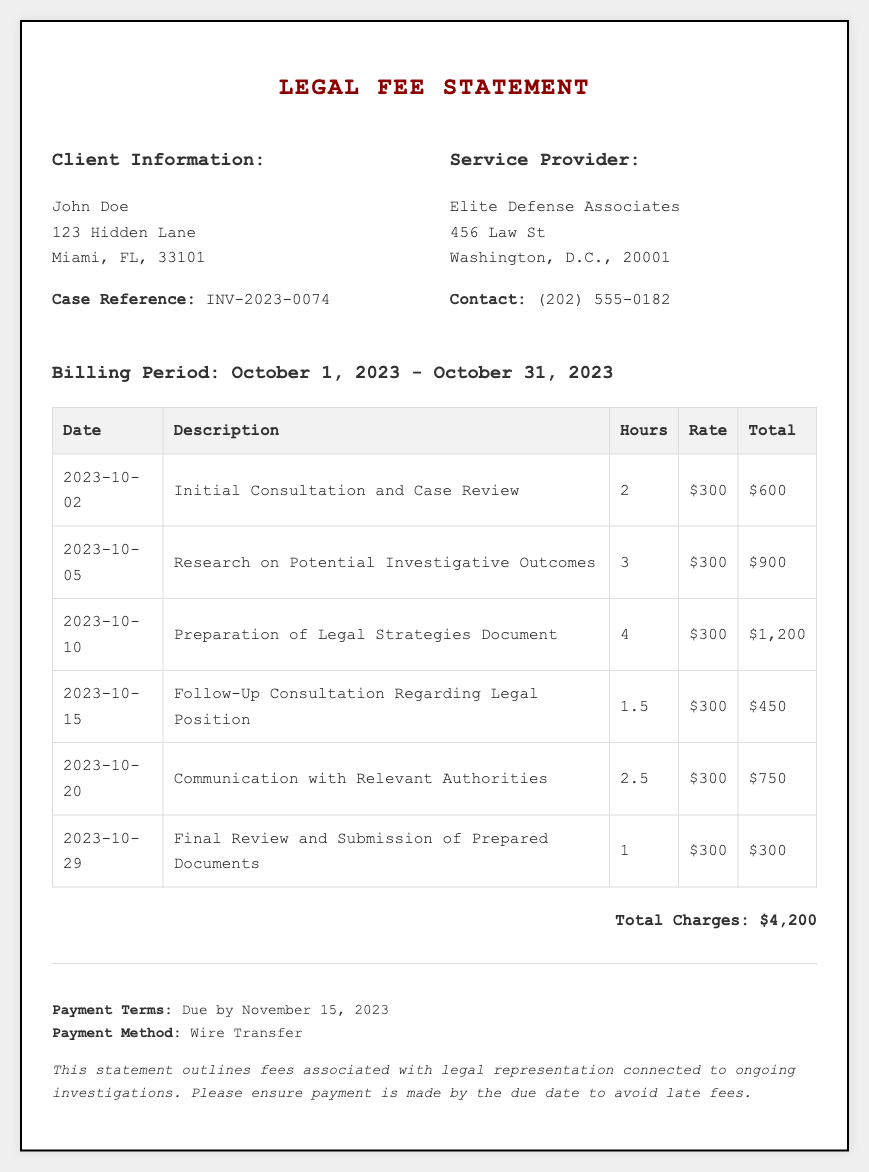What is the client's name? The client's name is presented at the top of the document under Client Information.
Answer: John Doe What is the total amount charged? The total amount charged is summarized at the bottom of the document in the total charges section.
Answer: $4,200 What is the billing period covered in this statement? The billing period is clearly mentioned in the header section of the document.
Answer: October 1, 2023 - October 31, 2023 How many hours were billed for the "Preparation of Legal Strategies Document"? The number of hours for this specific entry is listed in the corresponding row of the table.
Answer: 4 What was the rate per hour charged for services? The rate per hour is consistent across all entries in the table, found in the Rate column.
Answer: $300 What date was the "Final Review and Submission of Prepared Documents"? The date is the first entry in the corresponding row of the table for that service.
Answer: 2023-10-29 What type of payment method is accepted? The accepted payment method is mentioned in the footer of the document.
Answer: Wire Transfer How many consultations took place during the billing period? The number of consultations can be determined by counting the related entries in the table.
Answer: 2 What is the case reference number? The case reference number is explicitly listed under Client Information.
Answer: INV-2023-0074 